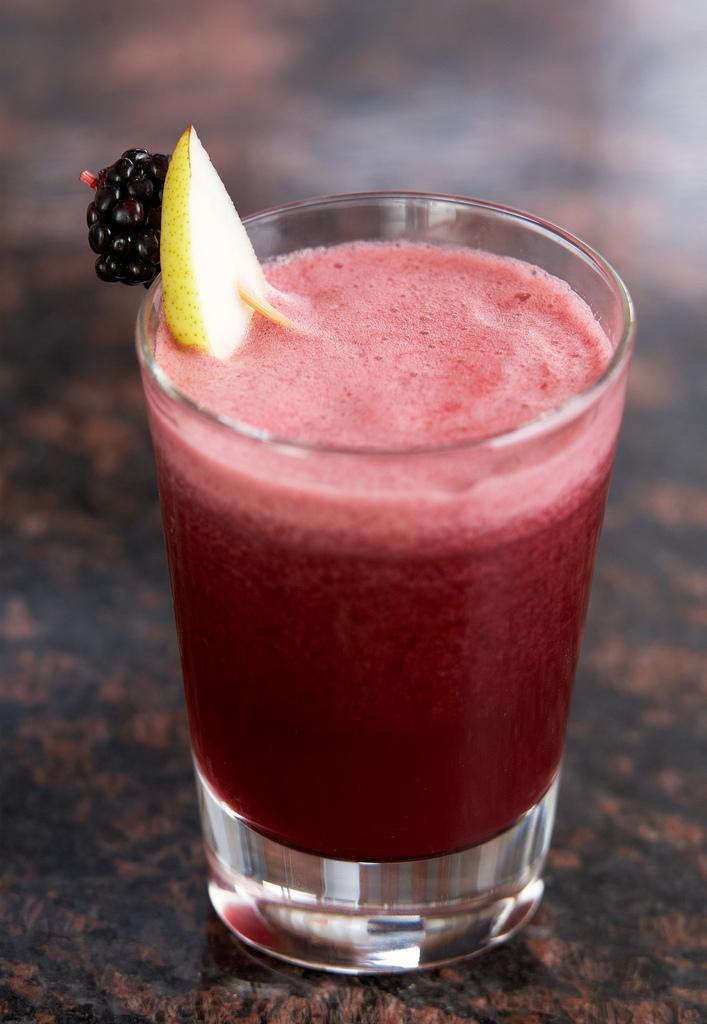In one or two sentences, can you explain what this image depicts? In this image I see a glass which is filled with a juice, which is of pink in color and there is also a fruit on top of the juice. 